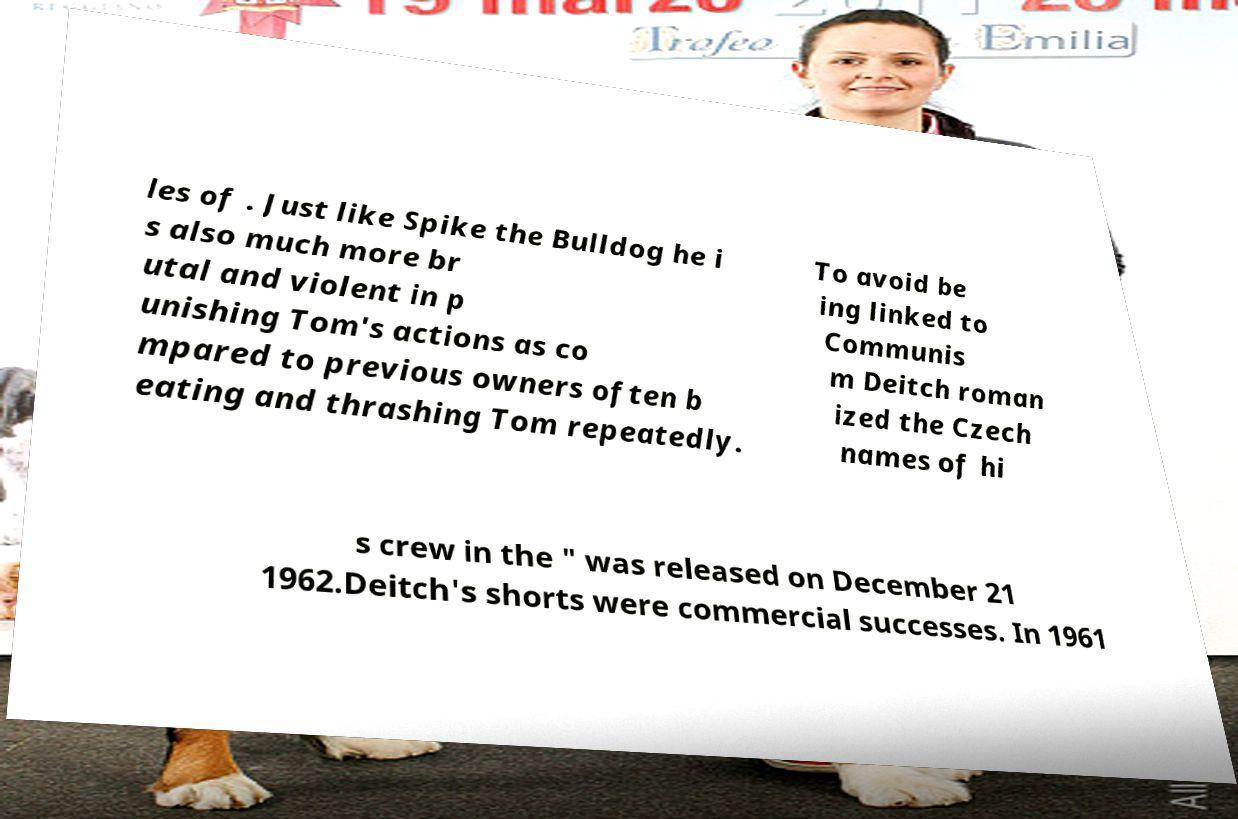Can you read and provide the text displayed in the image?This photo seems to have some interesting text. Can you extract and type it out for me? les of . Just like Spike the Bulldog he i s also much more br utal and violent in p unishing Tom's actions as co mpared to previous owners often b eating and thrashing Tom repeatedly. To avoid be ing linked to Communis m Deitch roman ized the Czech names of hi s crew in the " was released on December 21 1962.Deitch's shorts were commercial successes. In 1961 